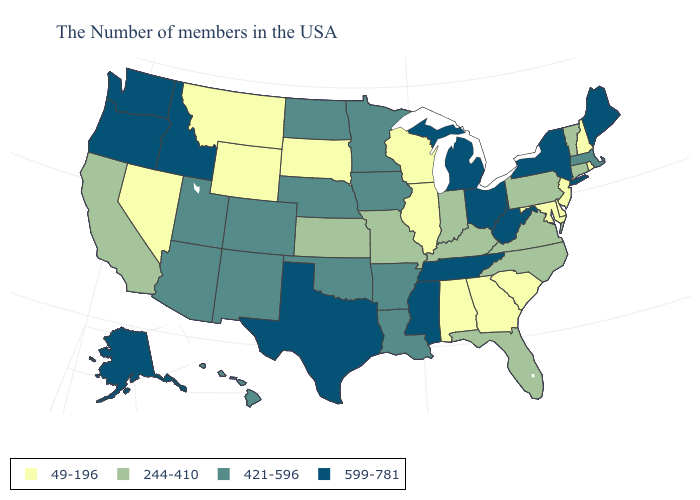How many symbols are there in the legend?
Short answer required. 4. How many symbols are there in the legend?
Quick response, please. 4. Name the states that have a value in the range 421-596?
Keep it brief. Massachusetts, Louisiana, Arkansas, Minnesota, Iowa, Nebraska, Oklahoma, North Dakota, Colorado, New Mexico, Utah, Arizona, Hawaii. Does Oregon have the highest value in the West?
Write a very short answer. Yes. What is the highest value in the USA?
Short answer required. 599-781. Does Missouri have a higher value than Illinois?
Give a very brief answer. Yes. What is the value of Washington?
Quick response, please. 599-781. What is the value of Illinois?
Be succinct. 49-196. Name the states that have a value in the range 244-410?
Quick response, please. Vermont, Connecticut, Pennsylvania, Virginia, North Carolina, Florida, Kentucky, Indiana, Missouri, Kansas, California. Does Washington have the same value as Texas?
Write a very short answer. Yes. What is the value of West Virginia?
Quick response, please. 599-781. Which states have the highest value in the USA?
Be succinct. Maine, New York, West Virginia, Ohio, Michigan, Tennessee, Mississippi, Texas, Idaho, Washington, Oregon, Alaska. What is the lowest value in the USA?
Give a very brief answer. 49-196. Does Florida have the same value as Pennsylvania?
Concise answer only. Yes. What is the highest value in the West ?
Concise answer only. 599-781. 